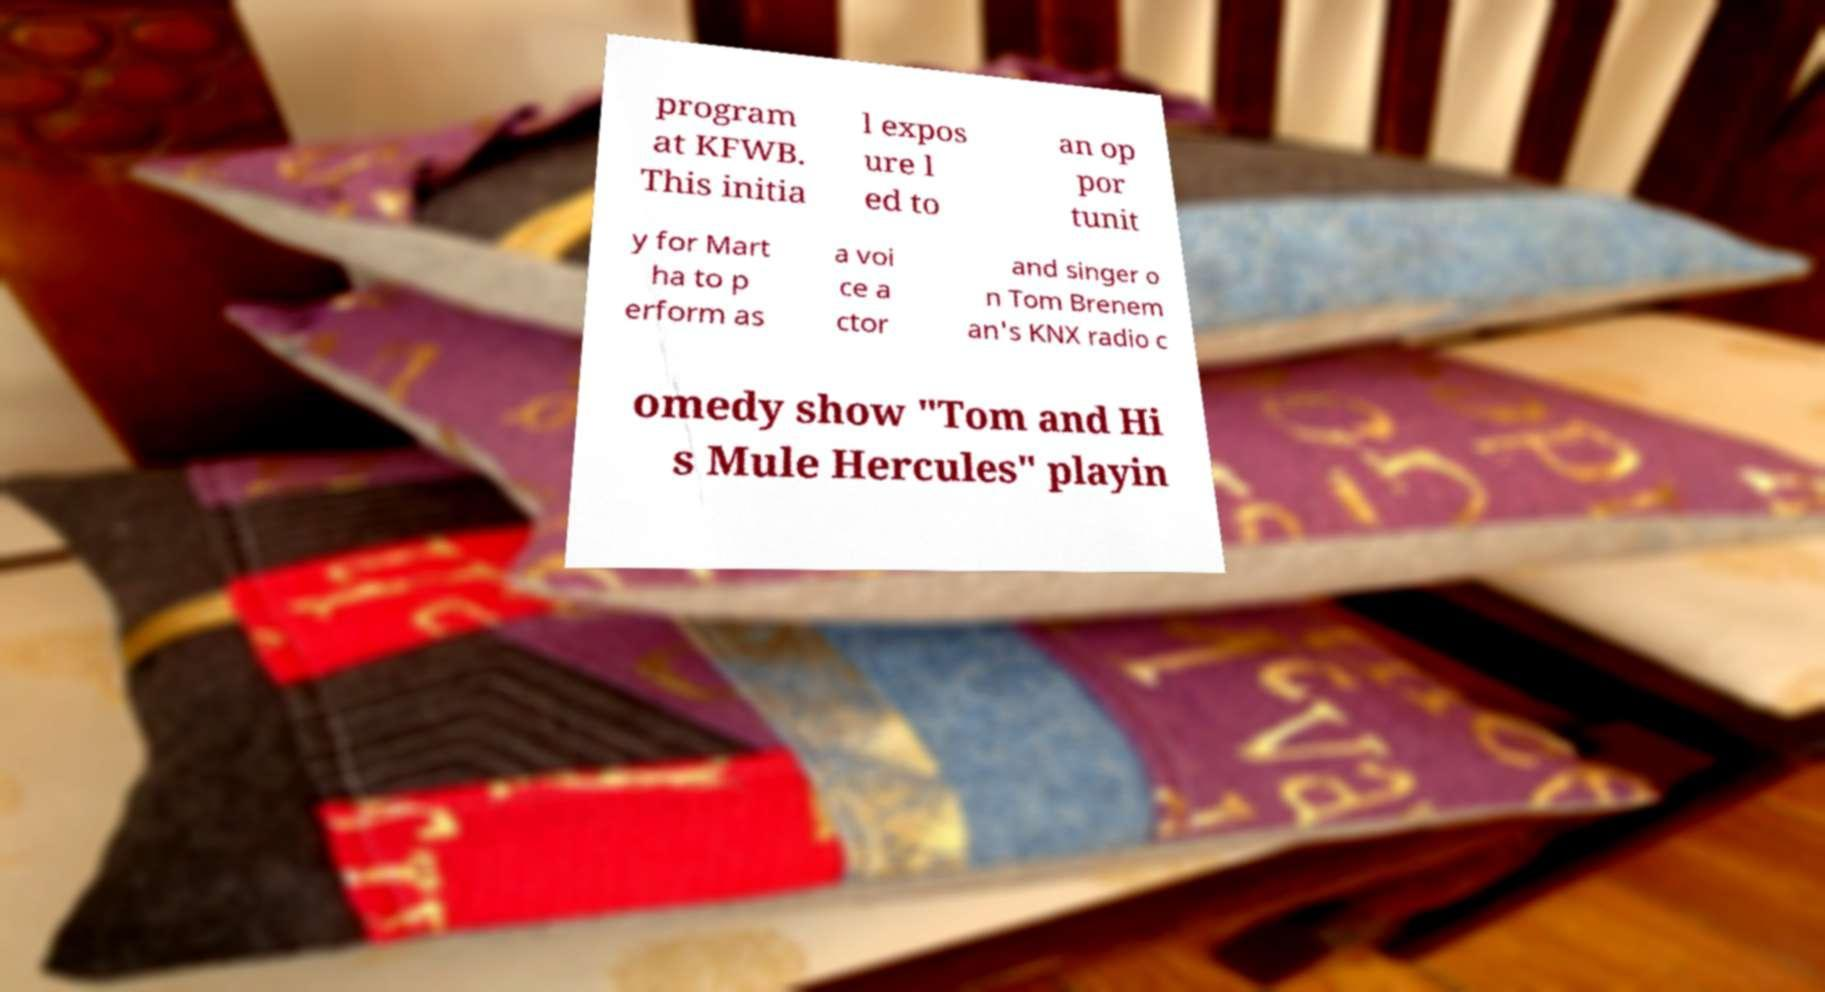I need the written content from this picture converted into text. Can you do that? program at KFWB. This initia l expos ure l ed to an op por tunit y for Mart ha to p erform as a voi ce a ctor and singer o n Tom Brenem an's KNX radio c omedy show "Tom and Hi s Mule Hercules" playin 